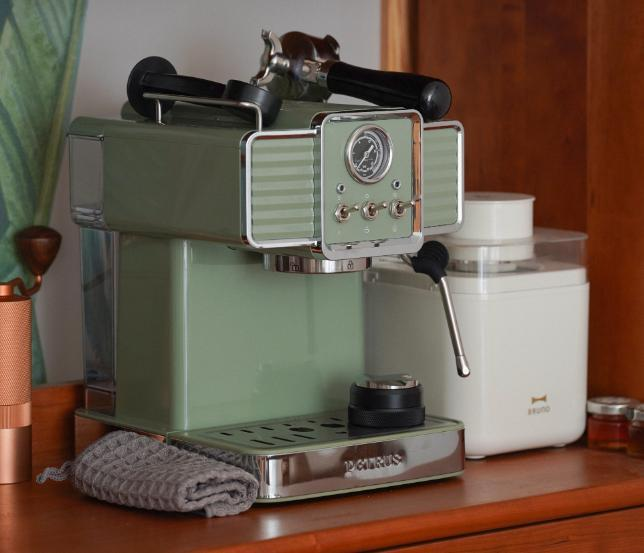图片中有哪些物品 图片中的物品包括：

1. 一台绿色的咖啡机，带有银色的底座和控制面板。
2. 咖啡机旁边放着一个灰色的织物抹布。
3. 咖啡机右侧有一个白色的容器，可能用于存放咖啡豆或其他物品。
4. 背景中有一些模糊的物品，看起来像是木制家具上的小物件。 